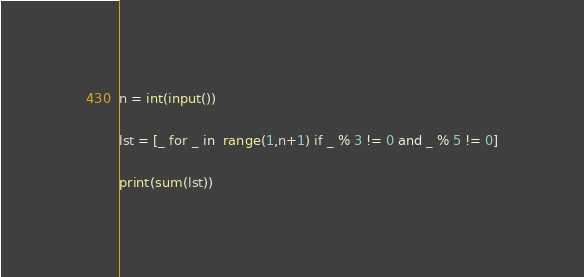Convert code to text. <code><loc_0><loc_0><loc_500><loc_500><_Python_>n = int(input())

lst = [_ for _ in  range(1,n+1) if _ % 3 != 0 and _ % 5 != 0]

print(sum(lst))</code> 